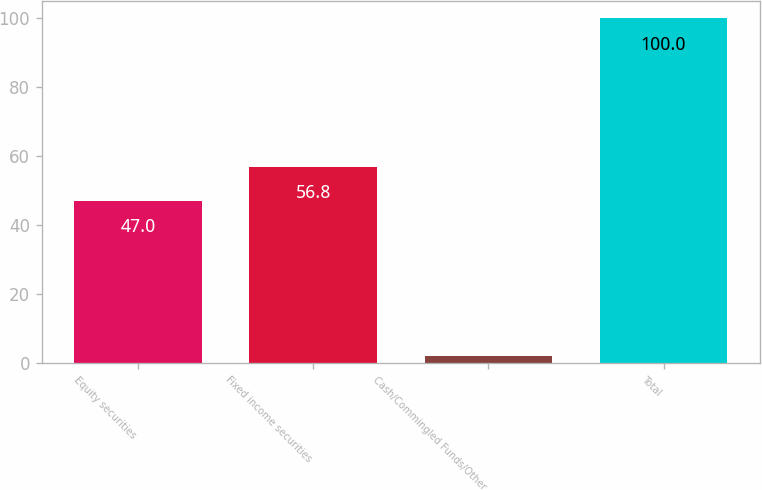<chart> <loc_0><loc_0><loc_500><loc_500><bar_chart><fcel>Equity securities<fcel>Fixed income securities<fcel>Cash/Commingled Funds/Other<fcel>Total<nl><fcel>47<fcel>56.8<fcel>2<fcel>100<nl></chart> 